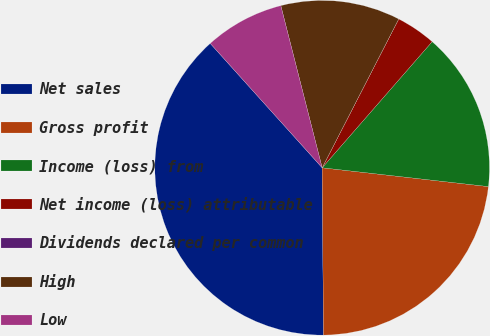Convert chart to OTSL. <chart><loc_0><loc_0><loc_500><loc_500><pie_chart><fcel>Net sales<fcel>Gross profit<fcel>Income (loss) from<fcel>Net income (loss) attributable<fcel>Dividends declared per common<fcel>High<fcel>Low<nl><fcel>38.46%<fcel>23.08%<fcel>15.38%<fcel>3.85%<fcel>0.0%<fcel>11.54%<fcel>7.69%<nl></chart> 